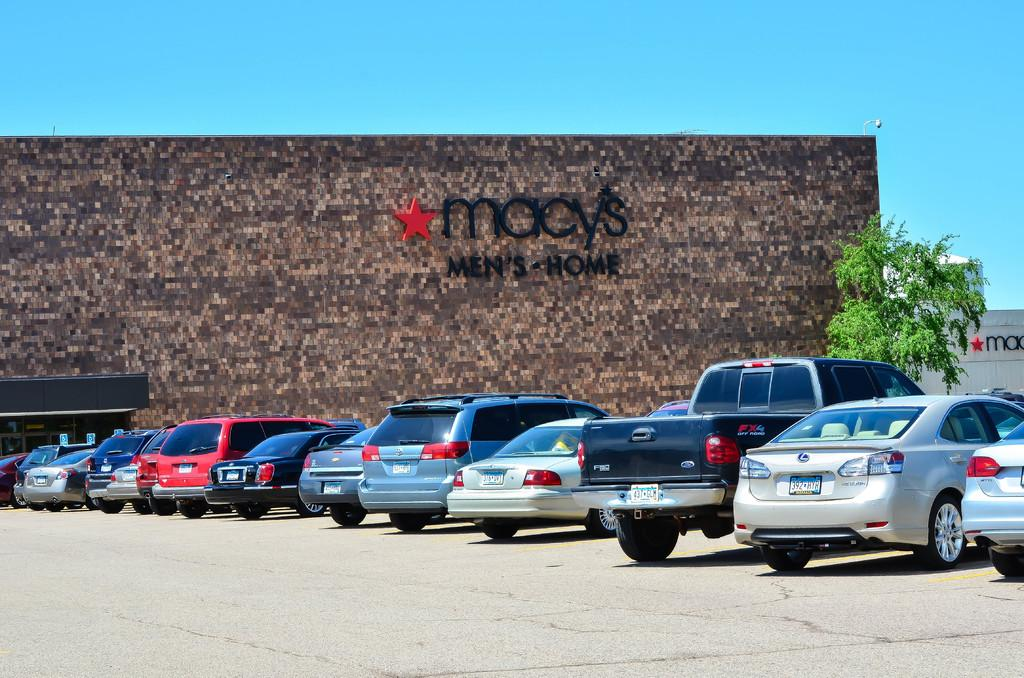What can be seen on the road in the image? There are vehicles on the road in the image. What type of vegetation is on the right side of the image? There is a tree on the right side of the image. What is written or depicted on the wall in the background of the image? There is a wall with text in the background of the image. What is visible in the sky in the image? The sky is visible in the image. How many rabbits can be seen playing on the wall in the image? There are no rabbits present in the image; the wall has text on it. What type of wrist accessory is visible on the tree in the image? There is no wrist accessory visible on the tree in the image; it is a tree with leaves or branches. 